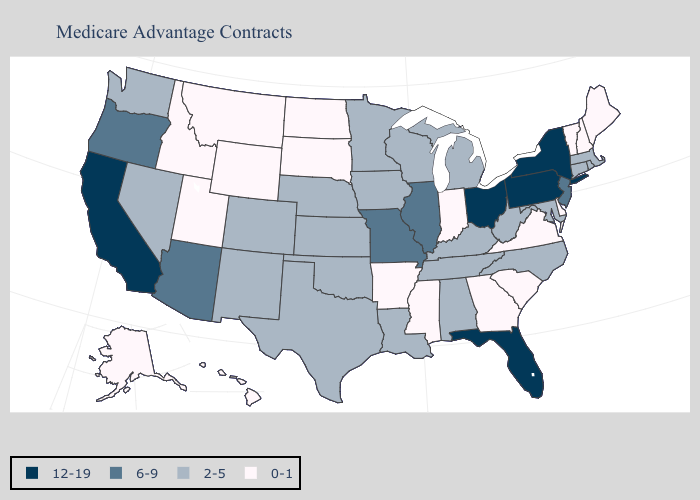Name the states that have a value in the range 0-1?
Quick response, please. Alaska, Arkansas, Delaware, Georgia, Hawaii, Idaho, Indiana, Maine, Mississippi, Montana, North Dakota, New Hampshire, South Carolina, South Dakota, Utah, Virginia, Vermont, Wyoming. Name the states that have a value in the range 6-9?
Quick response, please. Arizona, Illinois, Missouri, New Jersey, Oregon. What is the value of Montana?
Write a very short answer. 0-1. Among the states that border West Virginia , does Maryland have the highest value?
Short answer required. No. Name the states that have a value in the range 12-19?
Write a very short answer. California, Florida, New York, Ohio, Pennsylvania. Is the legend a continuous bar?
Quick response, please. No. What is the value of Tennessee?
Write a very short answer. 2-5. Among the states that border Massachusetts , which have the highest value?
Short answer required. New York. Does Florida have the lowest value in the South?
Be succinct. No. Which states hav the highest value in the West?
Concise answer only. California. Does Ohio have a higher value than Florida?
Concise answer only. No. Which states have the highest value in the USA?
Be succinct. California, Florida, New York, Ohio, Pennsylvania. What is the lowest value in states that border Rhode Island?
Give a very brief answer. 2-5. How many symbols are there in the legend?
Keep it brief. 4. What is the highest value in states that border Rhode Island?
Answer briefly. 2-5. 